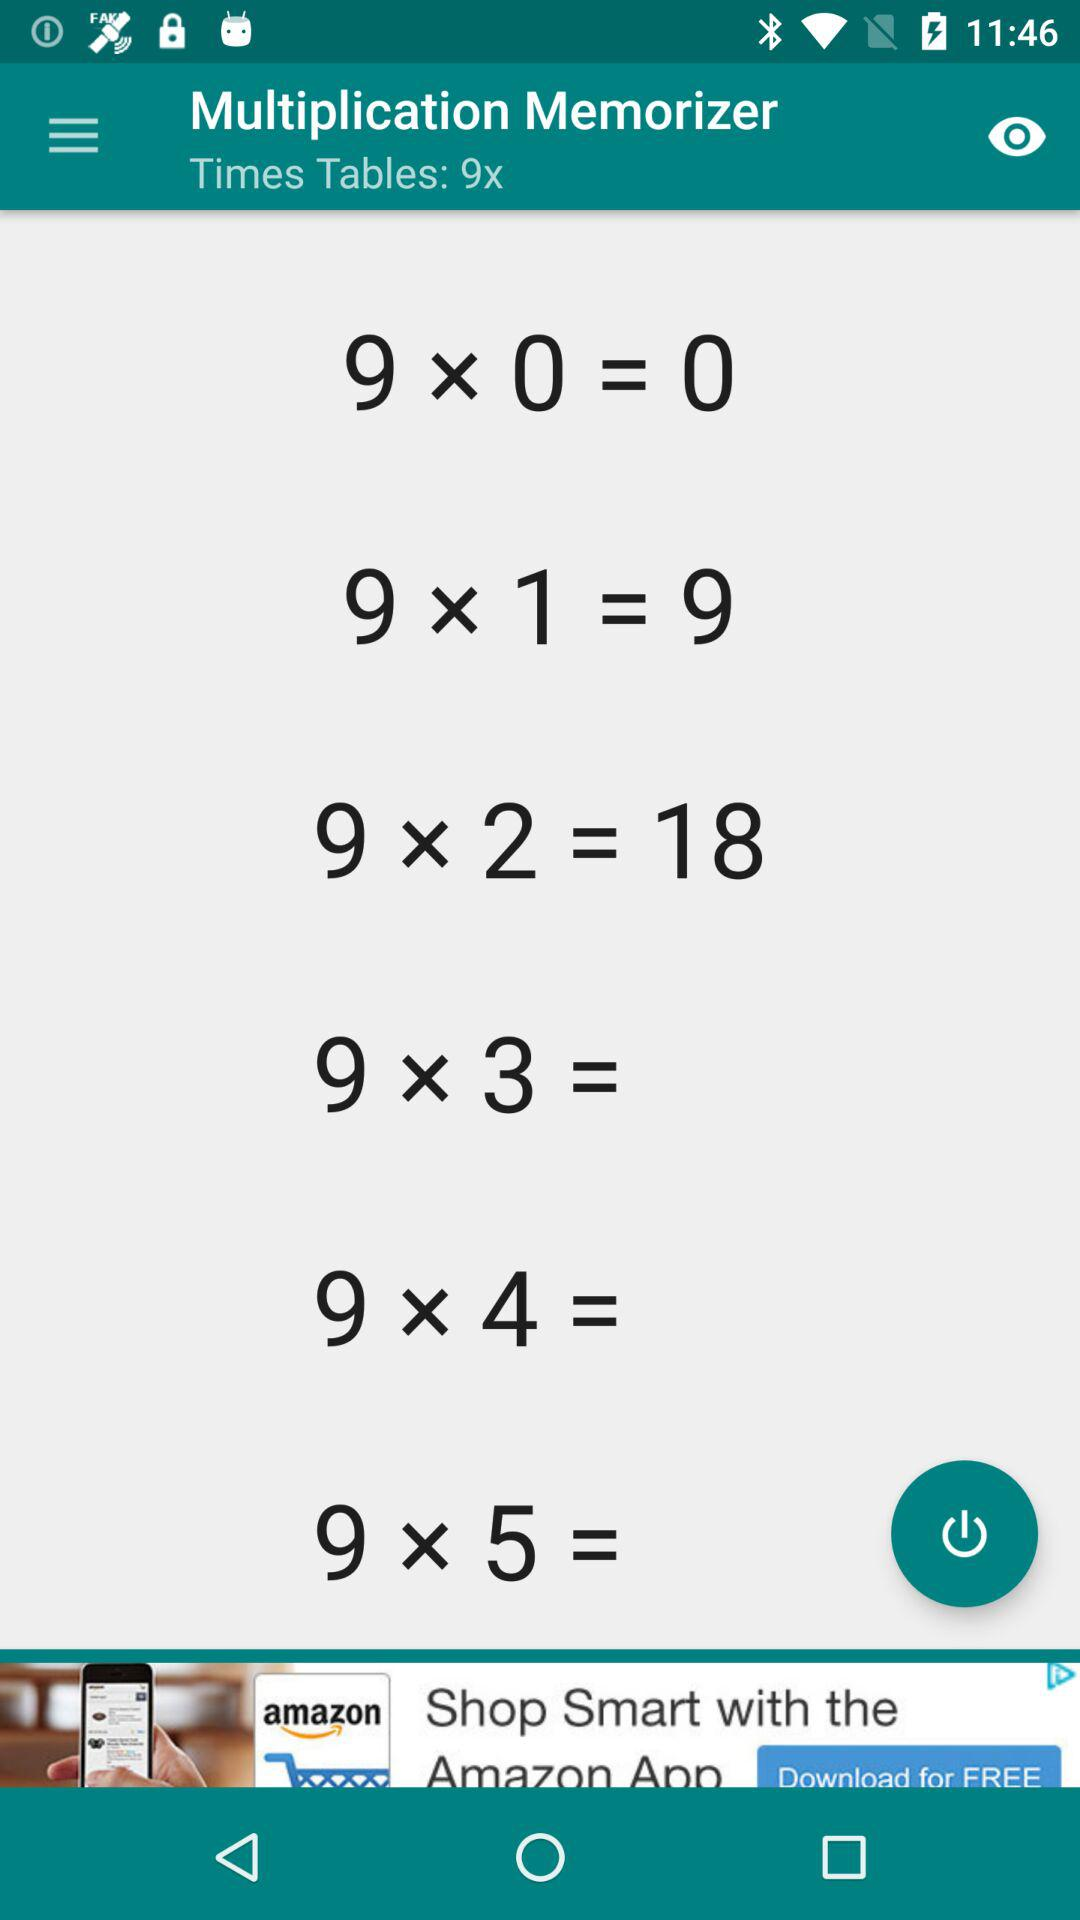What times table is given? The given times table is 9. 